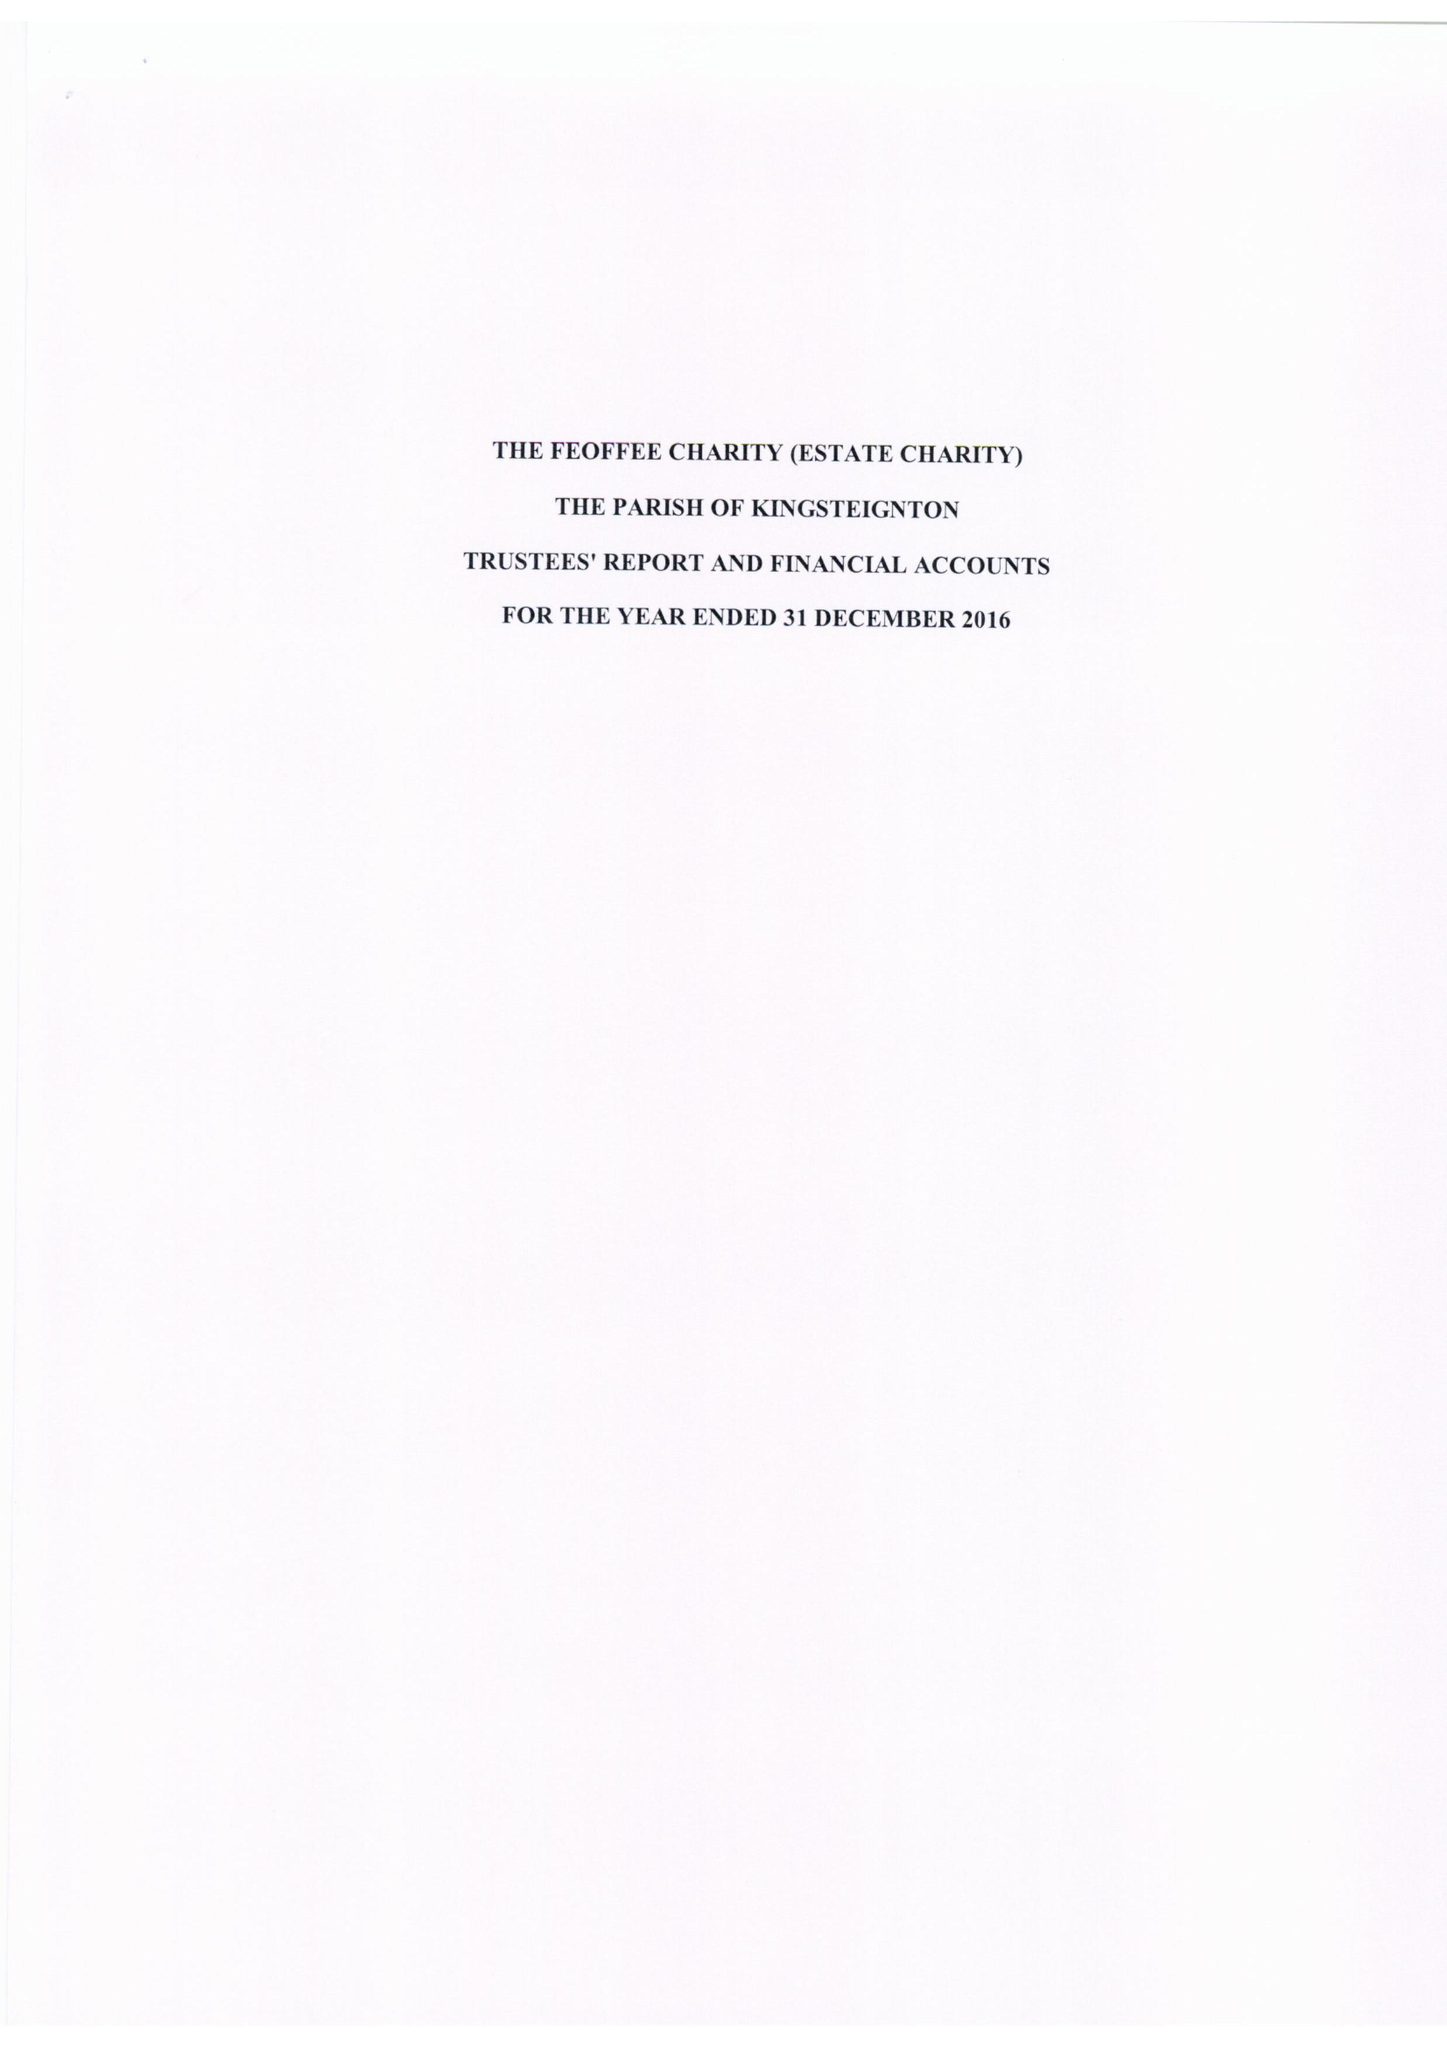What is the value for the report_date?
Answer the question using a single word or phrase. 2016-12-31 